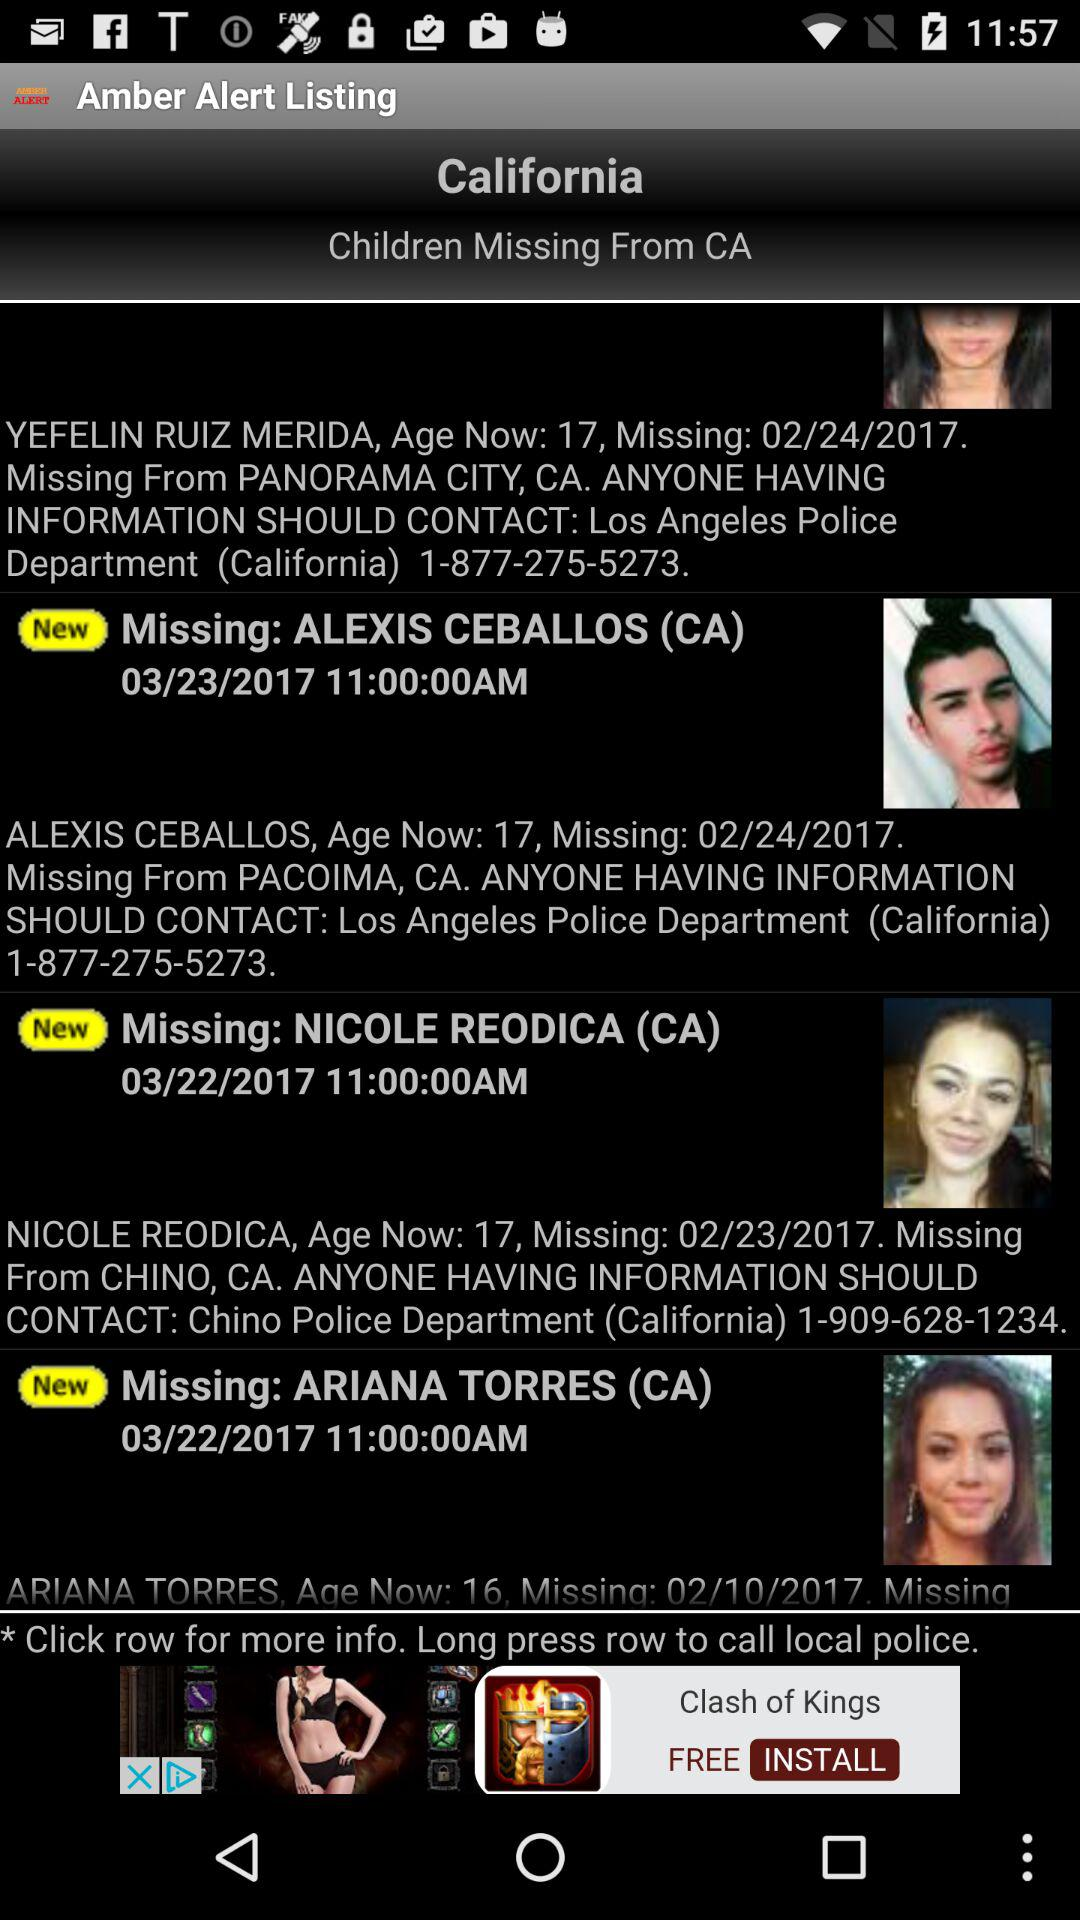What is the age of Alexis Ceballos? The age of Alexis Ceballos is 17 years. 